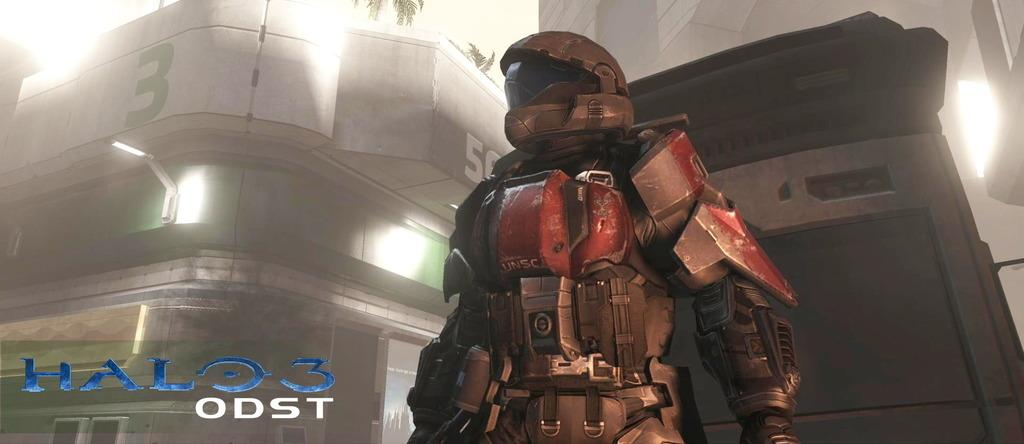What is the person in the image wearing? There is a person wearing a costume in the image. What can be seen in the background of the image? There are buildings with lights in the background of the image. Where is the text or writing located in the image? The text or writing is in the left bottom corner of the image. What advice does the ship's committee give in the image? There is no ship or committee present in the image, so it is not possible to answer that question. 